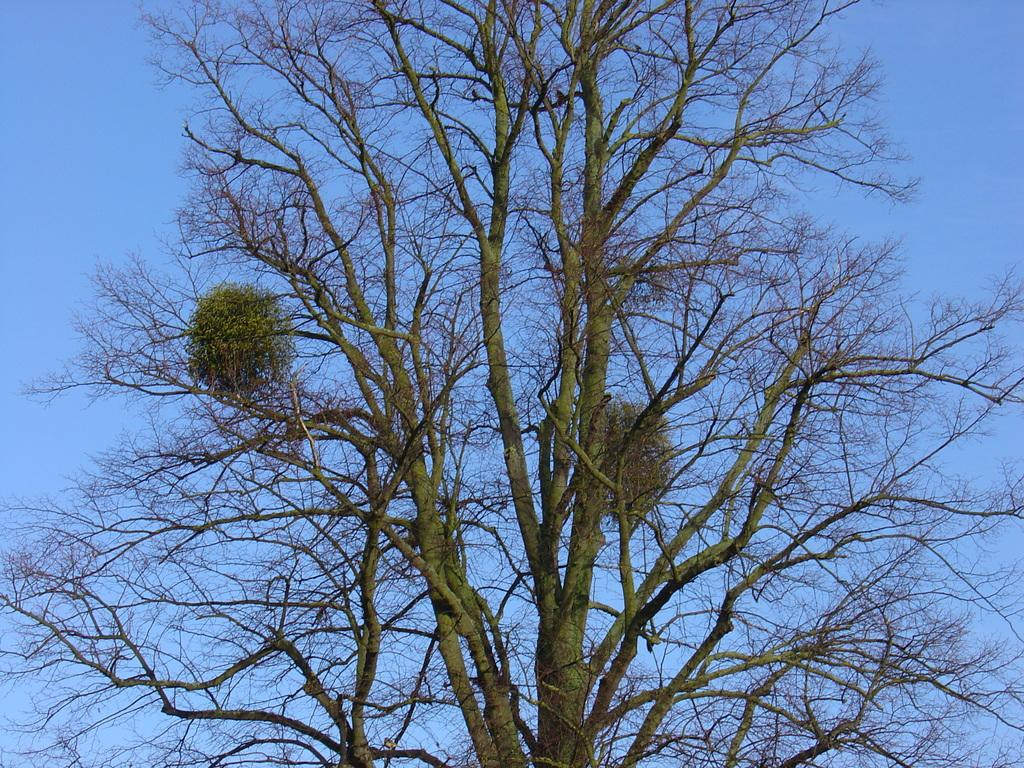What type of tree is in the image? There is a dried tree in the image. What part of the natural environment is visible in the image? The sky is visible in the image. What type of camera is being used by the band in the image? There is no camera or band present in the image; it features a dried tree and the sky. What tool is being used by the wrench in the image? There is no wrench present in the image; it features a dried tree and the sky. 